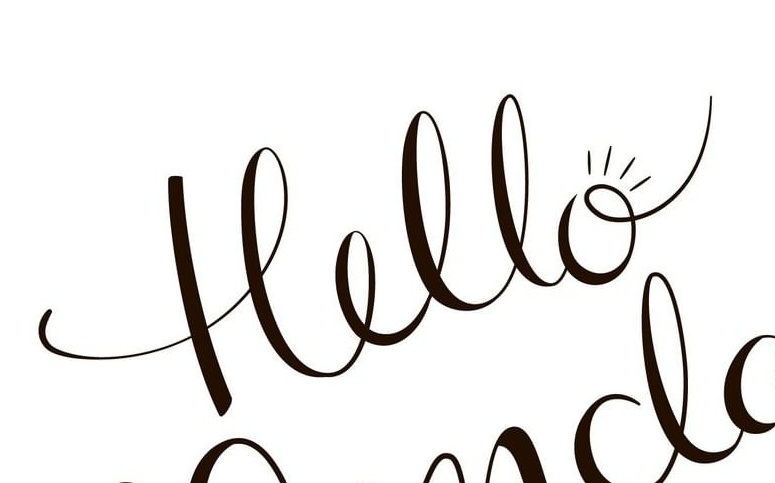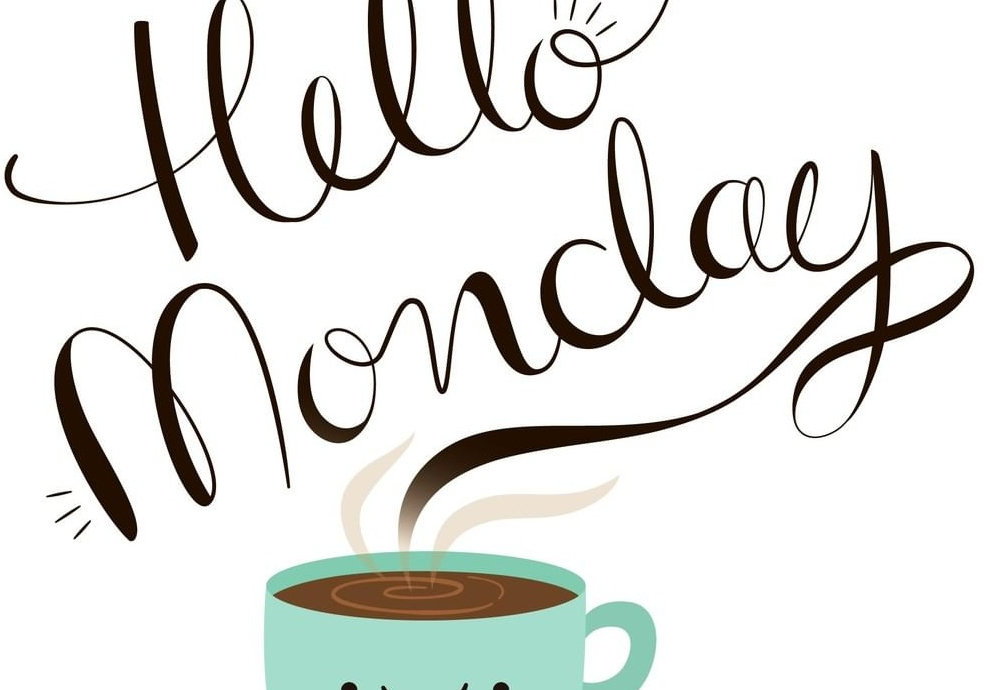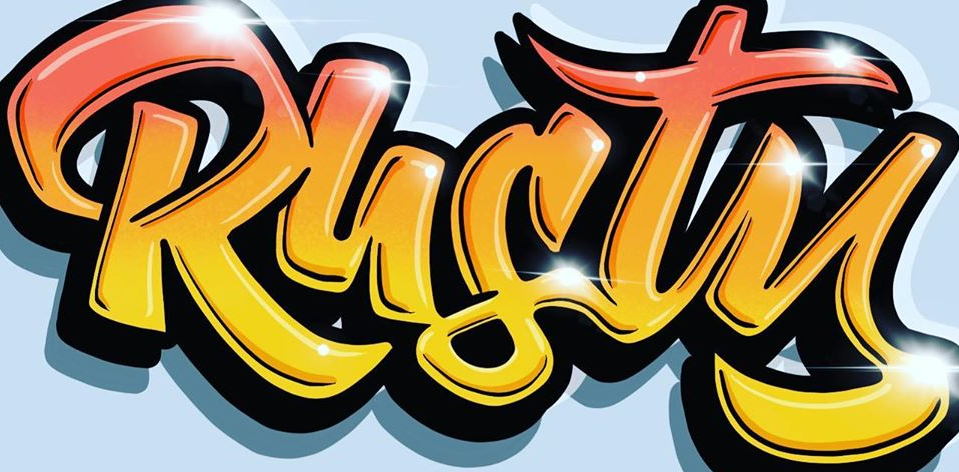Transcribe the words shown in these images in order, separated by a semicolon. Hello; Monday; Rusty 